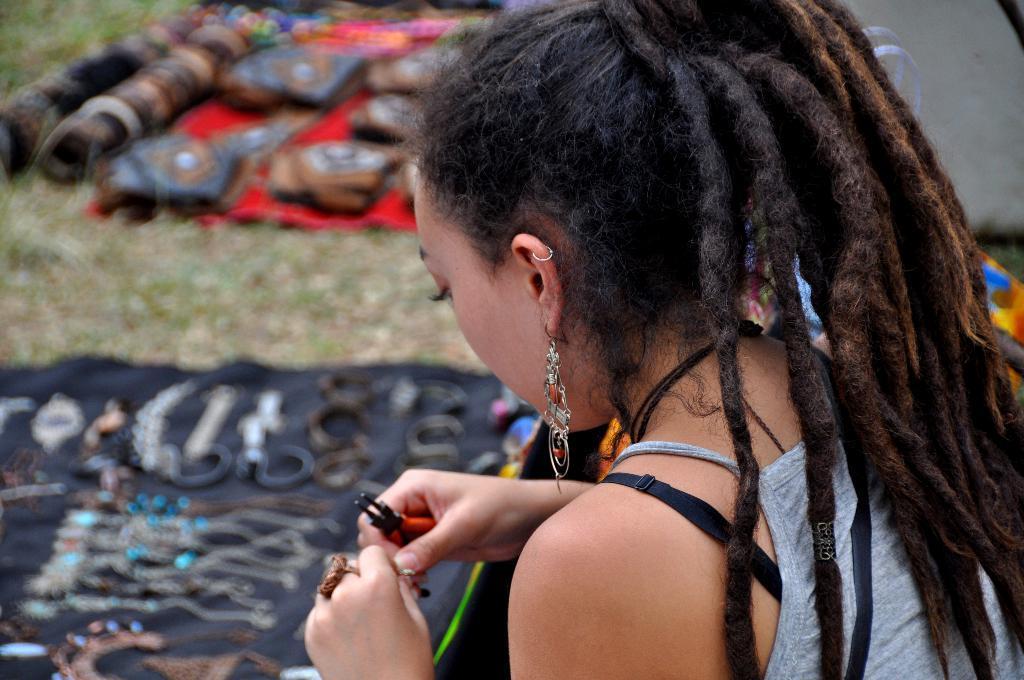Can you describe this image briefly? In this image in the foreground there is one woman who is holding something in her hand, and on the right side there are two clothes. On the clothes there are some bags and some ornaments, and in the center there is grass. 